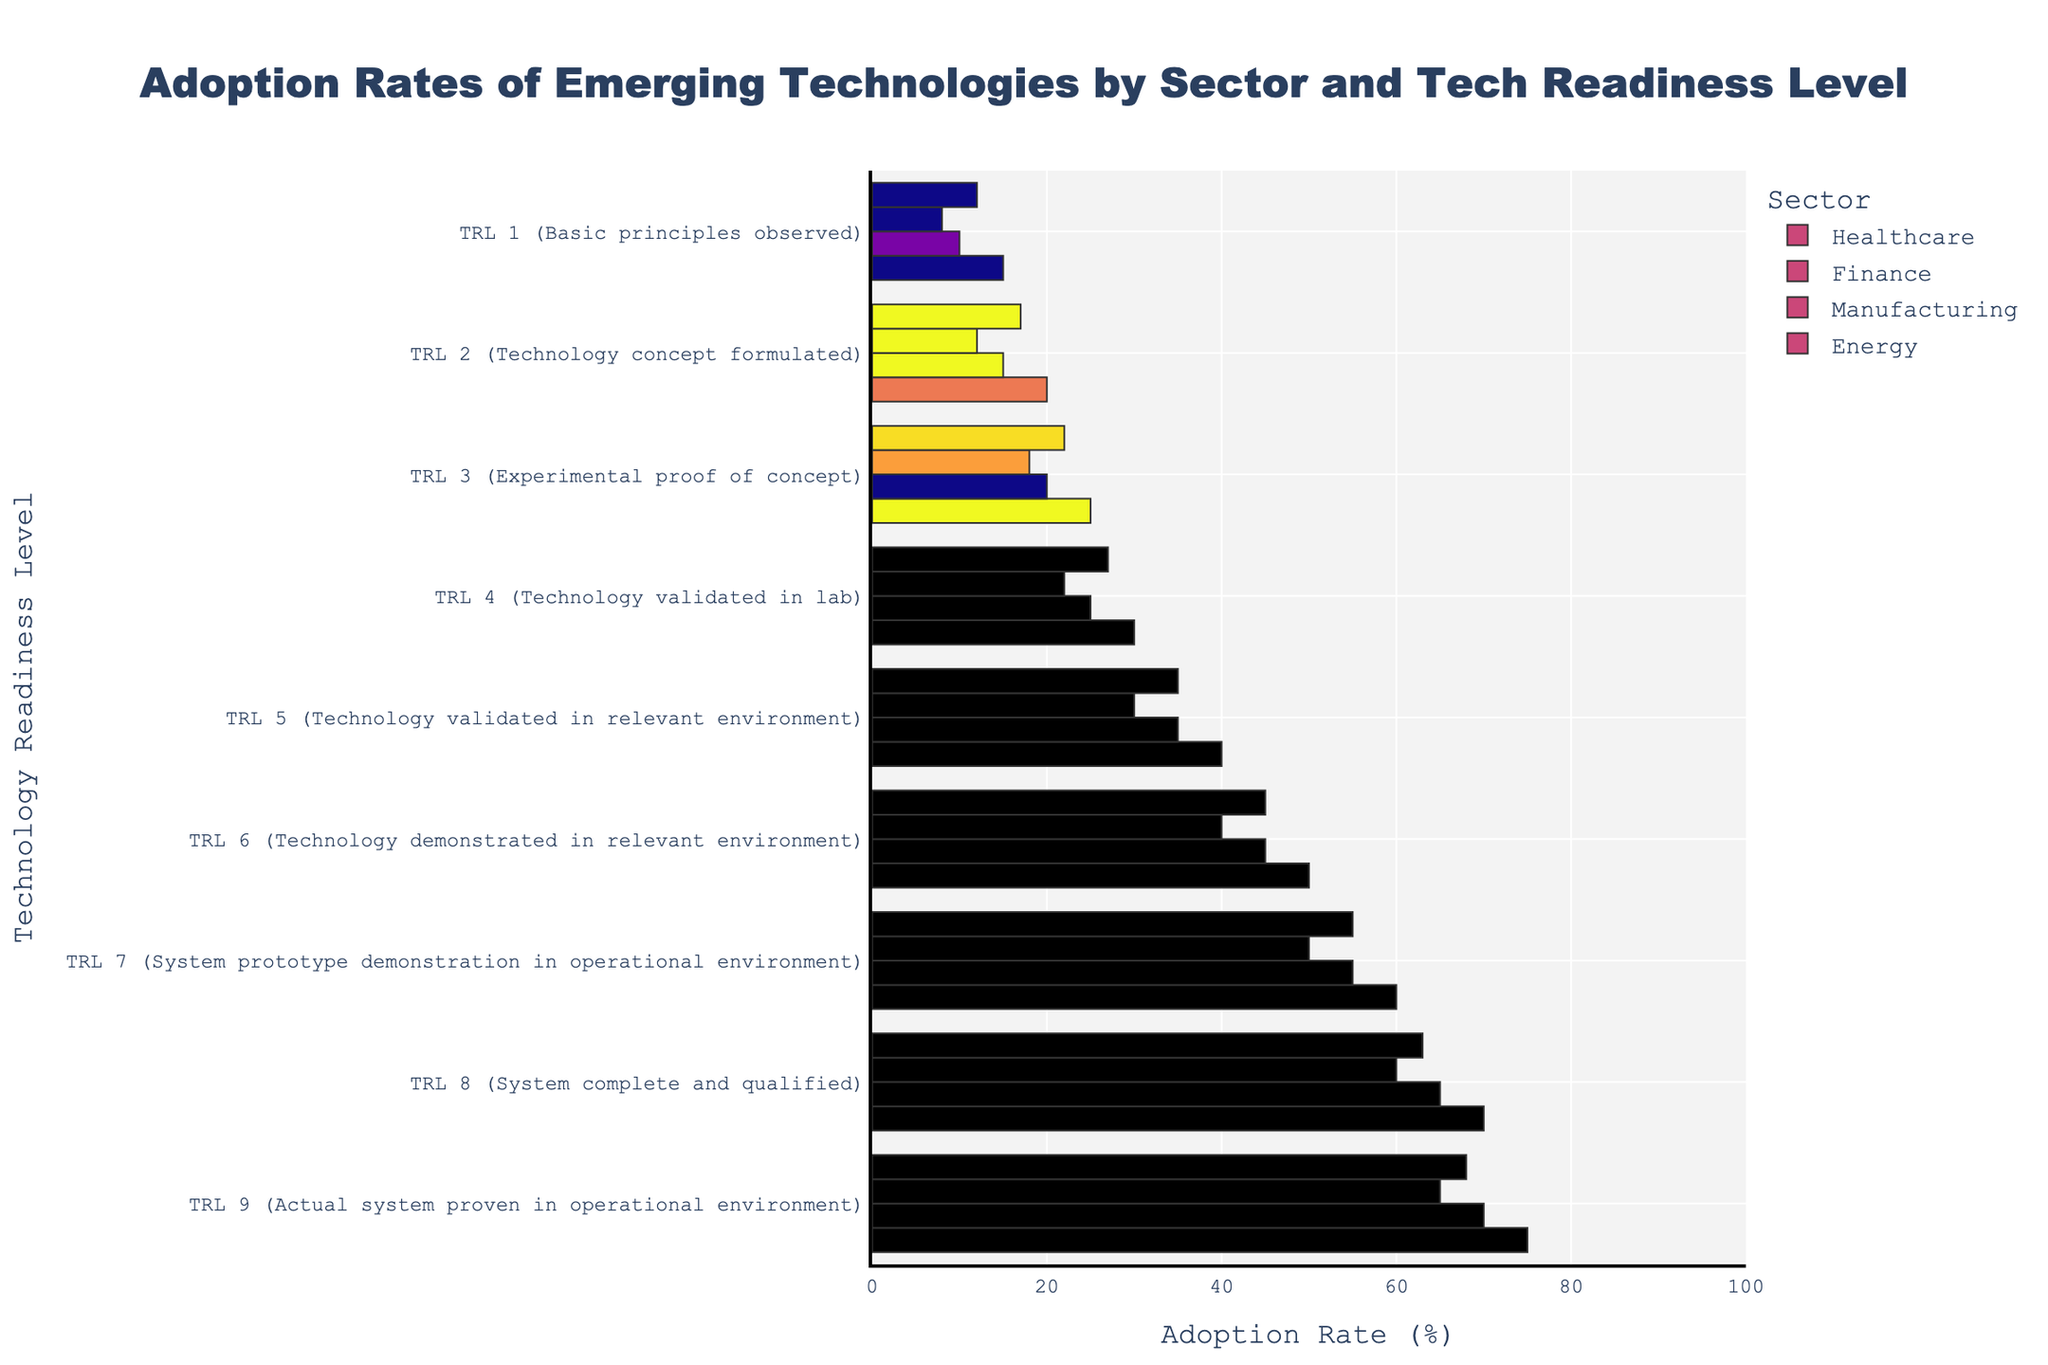What sector has the highest adoption rate at TRL 9? To find this, we need to look for the highest value in the TRL 9 category across all sectors. Checking the values: Healthcare (75), Finance (70), Manufacturing (65), Energy (68), Healthcare has the highest adoption rate at TRL 9.
Answer: Healthcare Which sector shows the greatest increase in adoption rate from TRL 5 to TRL 6? We look for the differences in adoption rates between TRL 5 and TRL 6 for each sector: Healthcare (50-40=10), Finance (45-35=10), Manufacturing (40-30=10), Energy (45-35=10). All sectors show the same increase, so the difference is equal.
Answer: All sectors Which tech readiness level has the highest adoption rate in the Energy sector? We need to find the highest value within the Energy sector. Looking at the values: TRL 1 (12), TRL 2 (17), TRL 3 (22), TRL 4 (27), TRL 5 (35), TRL 6 (45), TRL 7 (55), TRL 8 (63), TRL 9 (68), TRL 9 has the highest adoption rate.
Answer: TRL 9 How does the adoption rate in the Manufacturing sector at TRL 6 compare to that in Finance at the same level? We compare the values for TRL 6: Manufacturing (40), Finance (45). Finance has a higher adoption rate than Manufacturing at TRL 6.
Answer: Finance What is the combined adoption rate of TRL 8 for both the Healthcare and Finance sectors? To find this, add the TRL 8 values for Healthcare (70) and Finance (65). 70 + 65 = 135.
Answer: 135 Which sector has the lowest adoption rate at TRL 1? We need to identify the smallest value in the TRL 1 category: Healthcare (15), Finance (10), Manufacturing (8), Energy (12). Manufacturing has the lowest adoption rate at TRL 1.
Answer: Manufacturing What is the average adoption rate at TRL 3 across all sectors? Add up the TRL 3 values for all sectors and divide by the number of sectors: (25 + 20 + 18 + 22) / 4 = 85 / 4 = 21.25.
Answer: 21.25 Is the adoption rate at TRL 7 greater in Healthcare or in Energy? Comparing the TRL 7 values between Healthcare (60) and Energy (55). Healthcare has a higher adoption rate than Energy at TRL 7.
Answer: Healthcare By how much does the adoption rate in the Healthcare sector increase from TRL 4 to TRL 9? Subtract the TRL 4 value from the TRL 9 value for Healthcare: 75 - 30 = 45.
Answer: 45 